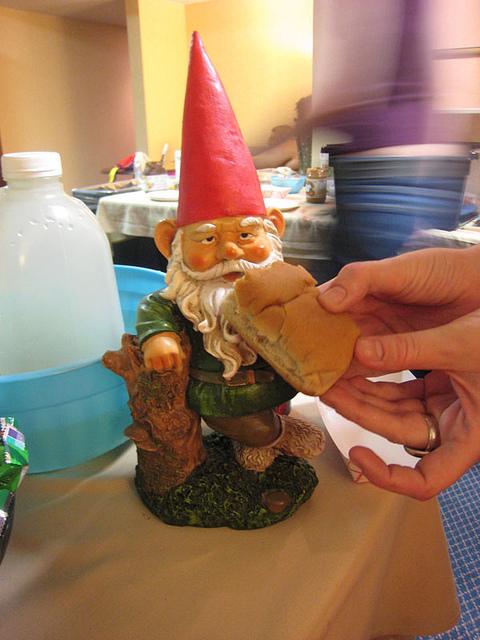What is the little man object called?
Quick response, please. Gnome. Is the background blurry?
Quick response, please. Yes. Can the gnome eat the bread?
Concise answer only. No. 